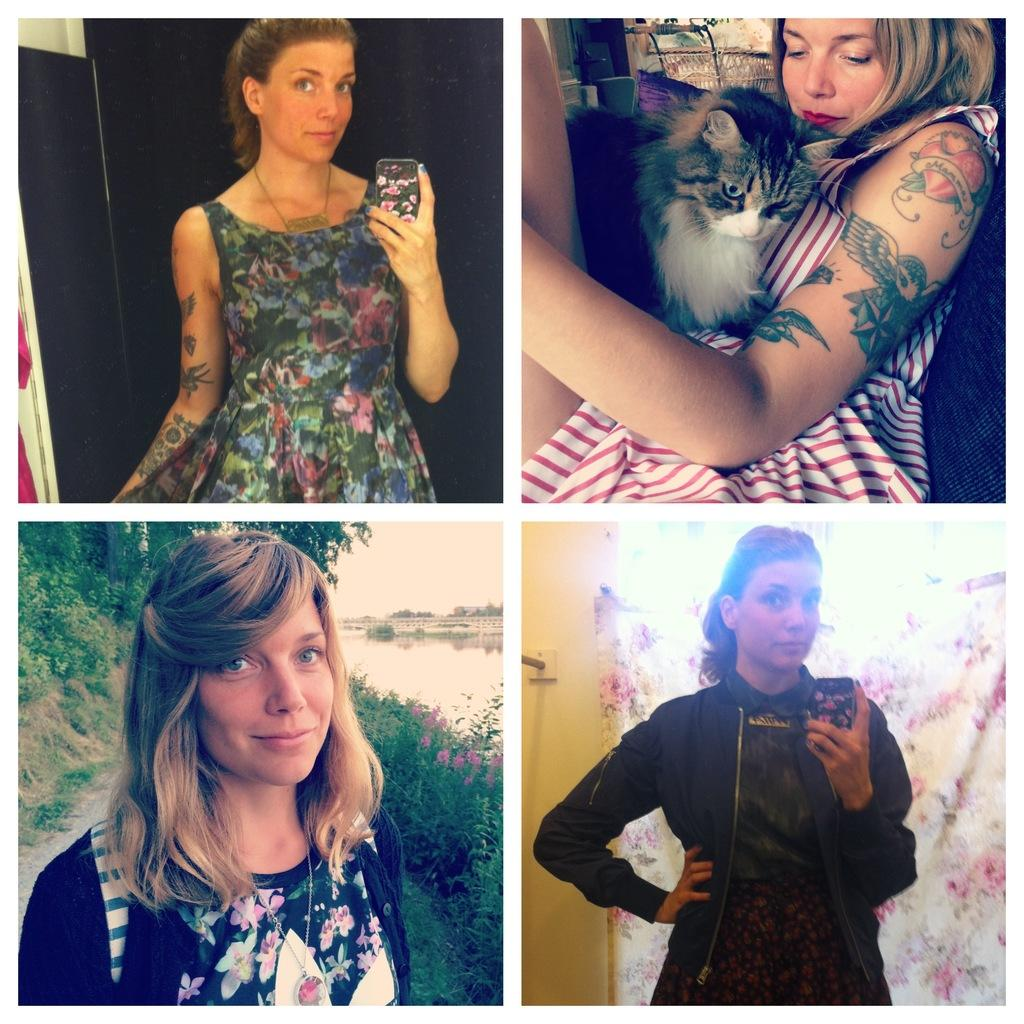What is the woman doing in the image? The woman is holding a mobile in one part of the image and carrying a cat in another part of the image. How is the woman feeling in the image? The woman is smiling in both parts of the image. What can be seen in the background of the image? There is water visible in the background of the image. How many feet are visible in the image? There is no mention of feet in the image, so it is not possible to determine how many are visible. 